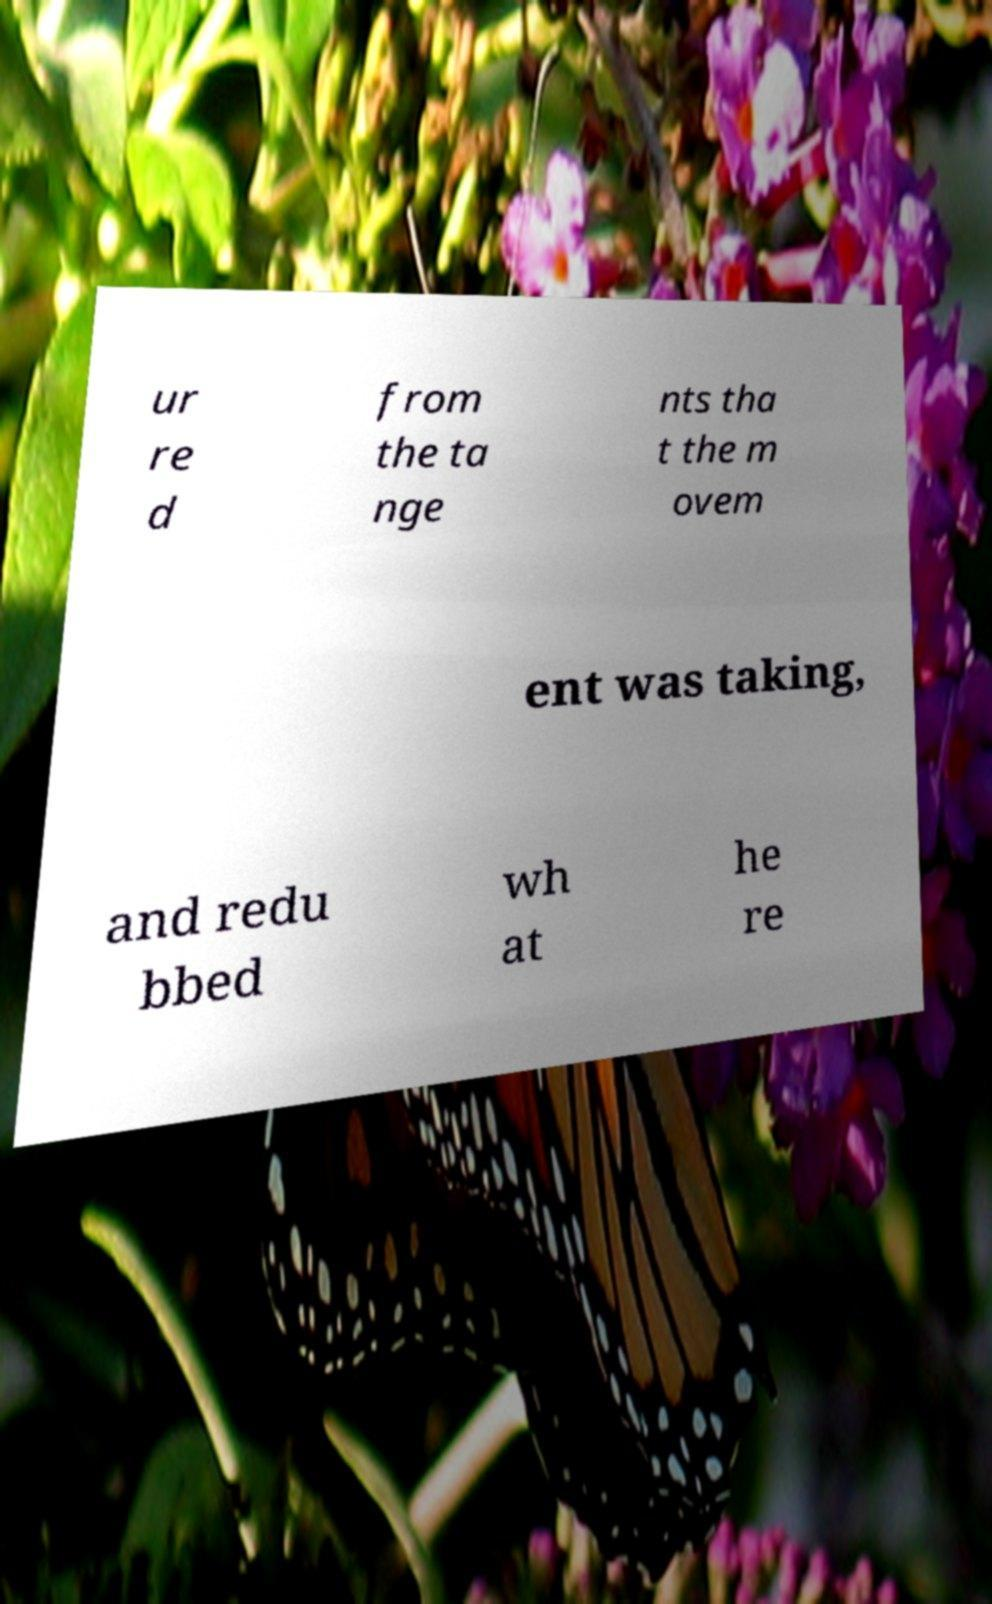Could you assist in decoding the text presented in this image and type it out clearly? ur re d from the ta nge nts tha t the m ovem ent was taking, and redu bbed wh at he re 